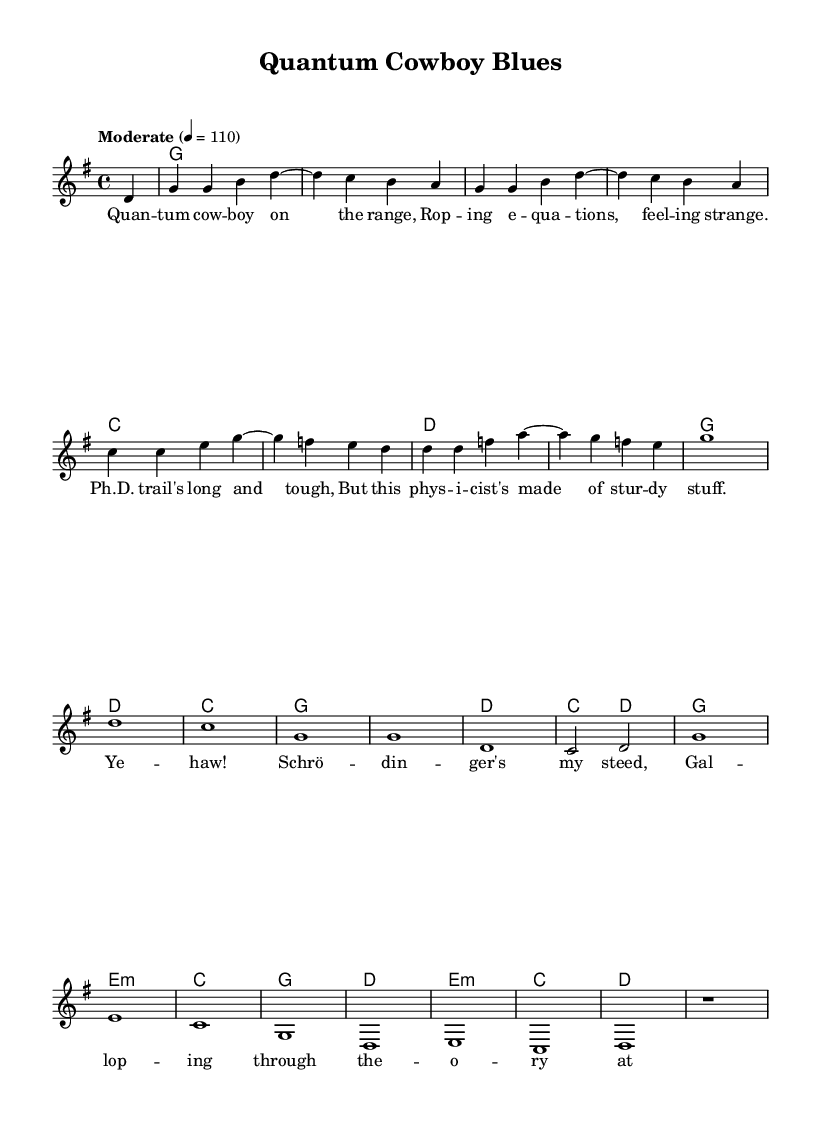What is the key signature of this music? The key signature indicates that the piece is in G major, which has one sharp (F#). This can be identified by looking at the key signature at the beginning of the staff.
Answer: G major What is the time signature of this music? The time signature is found at the start of the sheet music, indicating the piece has a 4/4 measure, meaning there are four beats per measure.
Answer: 4/4 What is the tempo of this piece? The tempo is labeled as "Moderate" with a marking of 4 = 110, which specifies the beats per minute. This label is typically found at the beginning of the score.
Answer: 110 How many measures are in the verse section? To determine the number of measures, we can count the number of bars in the verse lyrics. The verse consists of four lines, and each line contains four measures, totaling sixteen measures.
Answer: 16 What type of chord is used in the second measure? The second measure contains a G chord, which is indicated by the harmonies written above the melody part. In chord mode, it can be referenced directly in the score.
Answer: G What do the lyrics in the chorus refer to in terms of physics? The lyrics reference "Schrödinger" who is a famous physicist known for his contributions to quantum mechanics, which ties directly to the theme of the piece regarding pursuing a PhD in a science-related field.
Answer: Schrödinger What musical structure does the tune follow, generally describing its layout? The music appears to follow a standard verse-chorus structure, where after the verses are sung, the chorus repeats, a common format in country rock tunes that emphasizes storyline and emotion.
Answer: Verse-chorus 